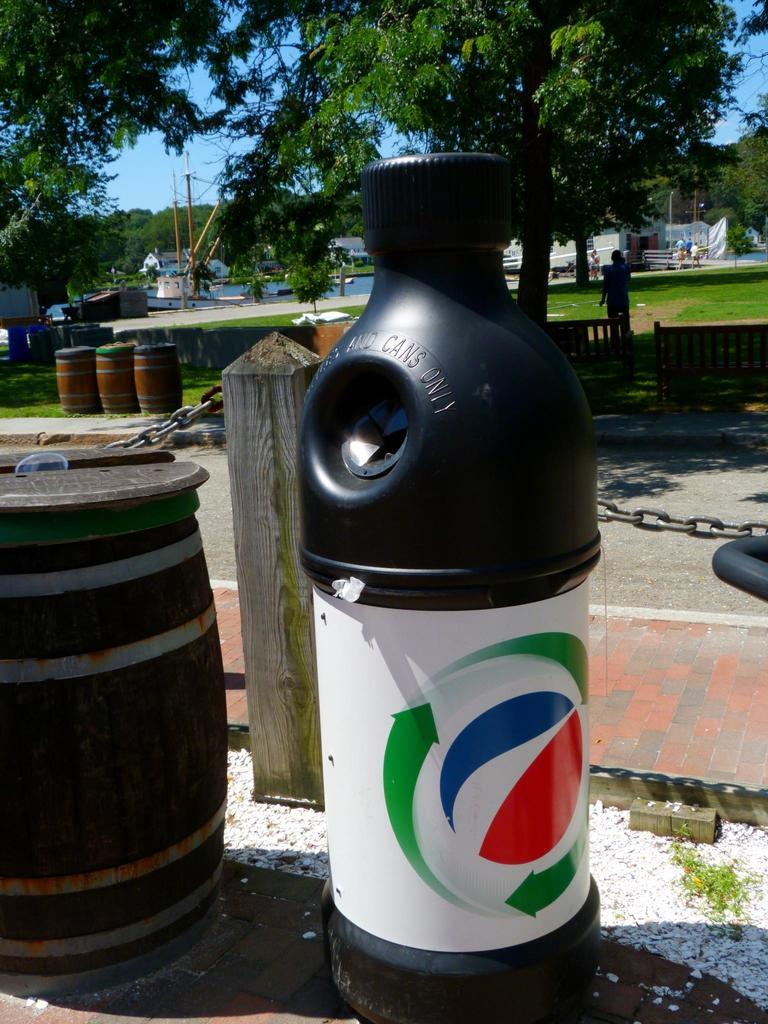What type of container is present in the image? There is a bottle-shaped container in the image. What other object is near the container? There is a barrel beside the container. Can you describe the person in the image? There is a person in the image, but no specific details about their appearance or actions are provided. What type of vegetation can be seen in the image? There are trees in the image. What type of stamp is the person using on the barrel in the image? There is no stamp present in the image, nor is there any indication that the person is using one. What action is the person performing with the trees in the image? There is no action involving the trees and the person in the image; the person's actions are not described. 